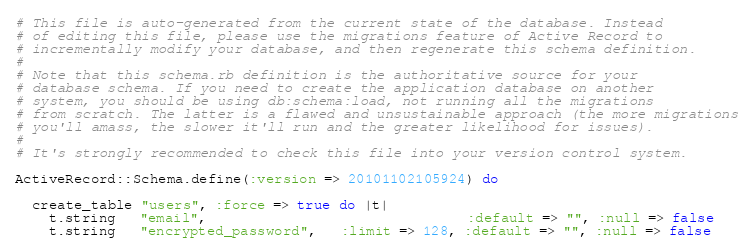<code> <loc_0><loc_0><loc_500><loc_500><_Ruby_># This file is auto-generated from the current state of the database. Instead
# of editing this file, please use the migrations feature of Active Record to
# incrementally modify your database, and then regenerate this schema definition.
#
# Note that this schema.rb definition is the authoritative source for your
# database schema. If you need to create the application database on another
# system, you should be using db:schema:load, not running all the migrations
# from scratch. The latter is a flawed and unsustainable approach (the more migrations
# you'll amass, the slower it'll run and the greater likelihood for issues).
#
# It's strongly recommended to check this file into your version control system.

ActiveRecord::Schema.define(:version => 20101102105924) do

  create_table "users", :force => true do |t|
    t.string   "email",                               :default => "", :null => false
    t.string   "encrypted_password",   :limit => 128, :default => "", :null => false</code> 